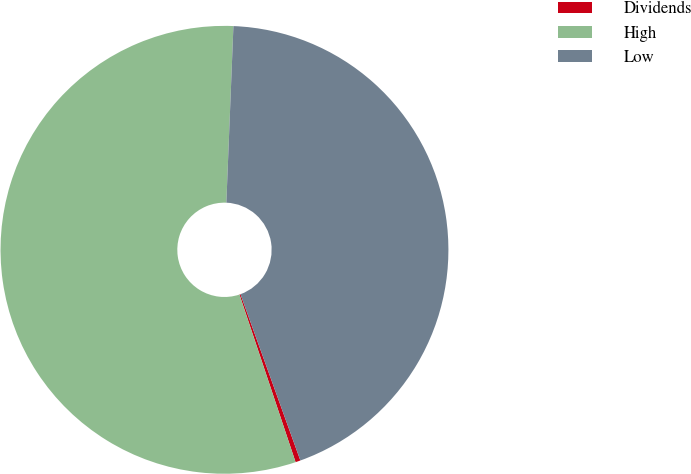Convert chart. <chart><loc_0><loc_0><loc_500><loc_500><pie_chart><fcel>Dividends<fcel>High<fcel>Low<nl><fcel>0.36%<fcel>55.78%<fcel>43.86%<nl></chart> 